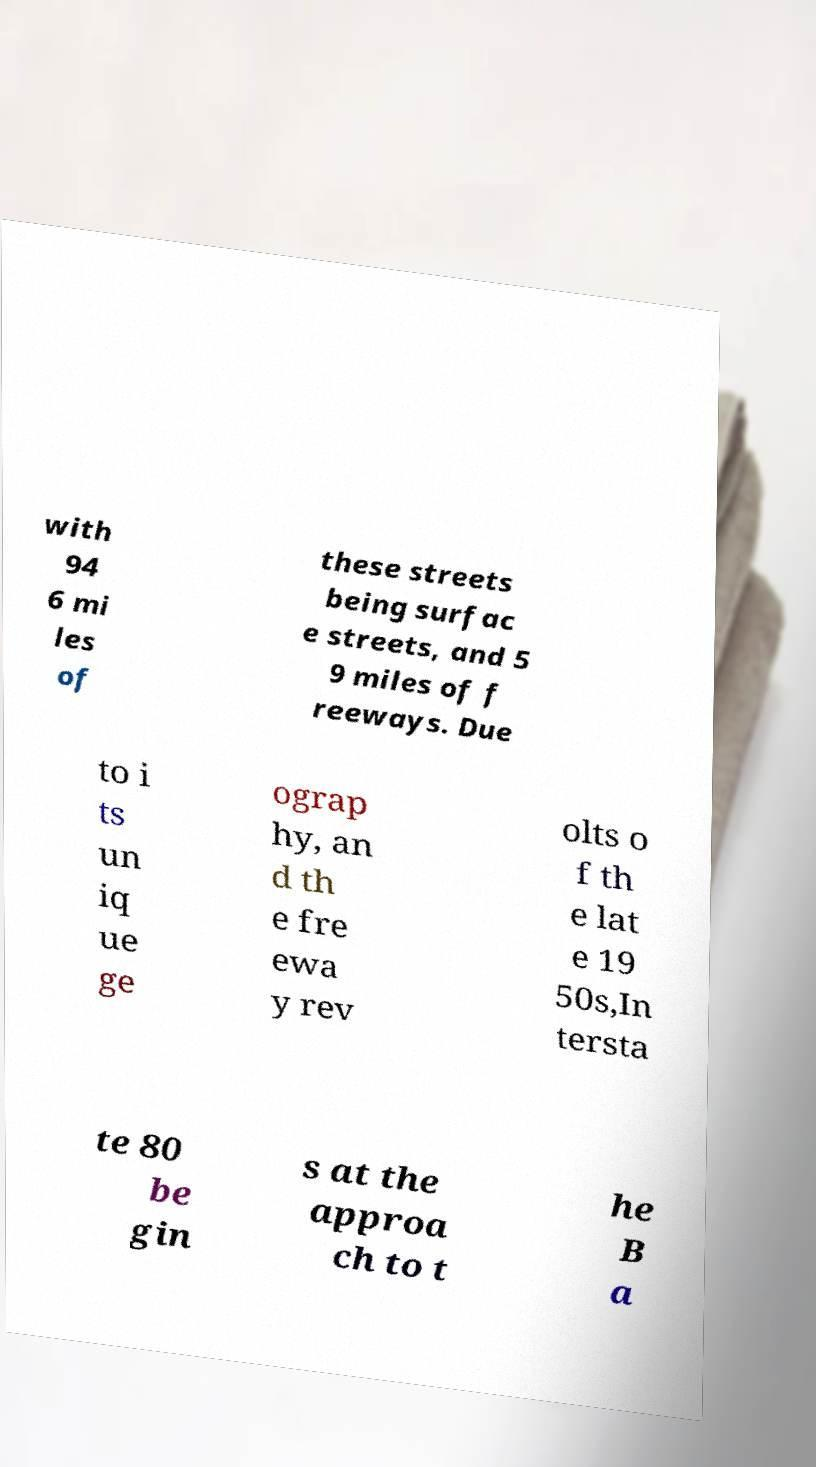There's text embedded in this image that I need extracted. Can you transcribe it verbatim? with 94 6 mi les of these streets being surfac e streets, and 5 9 miles of f reeways. Due to i ts un iq ue ge ograp hy, an d th e fre ewa y rev olts o f th e lat e 19 50s,In tersta te 80 be gin s at the approa ch to t he B a 